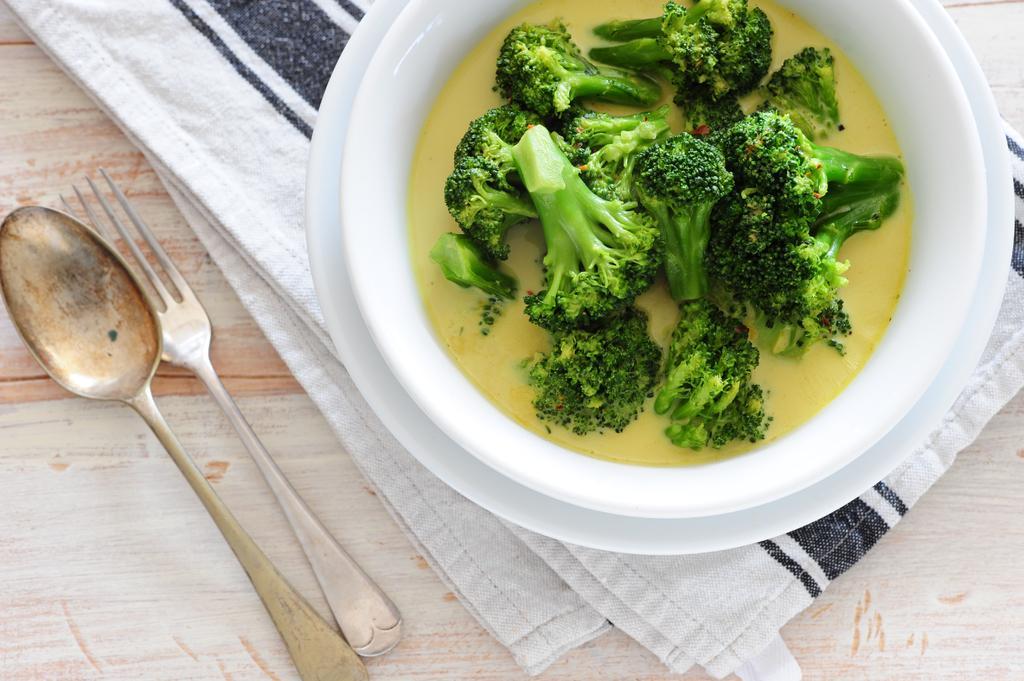Could you give a brief overview of what you see in this image? In this image, we can see food in the bowl and there are spoons and we can see clothes on the table. 